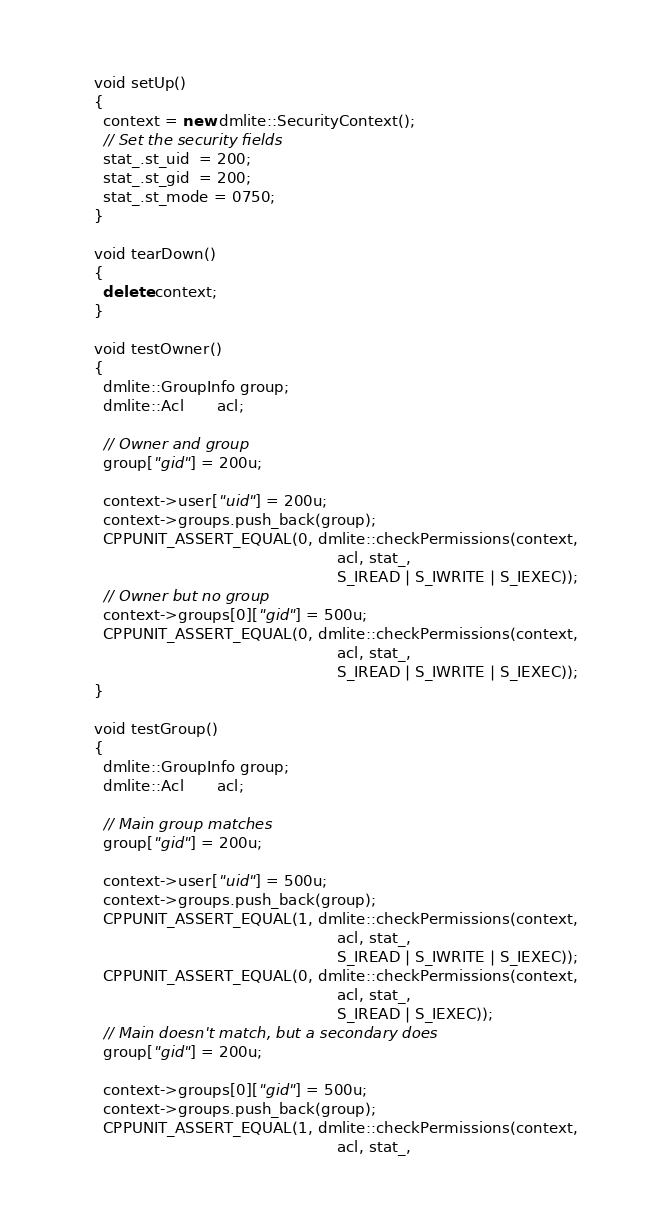Convert code to text. <code><loc_0><loc_0><loc_500><loc_500><_C++_>  void setUp()
  {
    context = new dmlite::SecurityContext();
    // Set the security fields
    stat_.st_uid  = 200;
    stat_.st_gid  = 200;
    stat_.st_mode = 0750;
  }

  void tearDown()
  {
    delete context;
  }

  void testOwner()
  {
    dmlite::GroupInfo group;
    dmlite::Acl       acl;
    
    // Owner and group
    group["gid"] = 200u;
    
    context->user["uid"] = 200u;
    context->groups.push_back(group);
    CPPUNIT_ASSERT_EQUAL(0, dmlite::checkPermissions(context,
                                                     acl, stat_,
                                                     S_IREAD | S_IWRITE | S_IEXEC));
    // Owner but no group
    context->groups[0]["gid"] = 500u;
    CPPUNIT_ASSERT_EQUAL(0, dmlite::checkPermissions(context,
                                                     acl, stat_,
                                                     S_IREAD | S_IWRITE | S_IEXEC));
  }

  void testGroup()
  {
    dmlite::GroupInfo group;
    dmlite::Acl       acl;
    
    // Main group matches
    group["gid"] = 200u;
    
    context->user["uid"] = 500u;
    context->groups.push_back(group);
    CPPUNIT_ASSERT_EQUAL(1, dmlite::checkPermissions(context,
                                                     acl, stat_,
                                                     S_IREAD | S_IWRITE | S_IEXEC));
    CPPUNIT_ASSERT_EQUAL(0, dmlite::checkPermissions(context,
                                                     acl, stat_,
                                                     S_IREAD | S_IEXEC));
    // Main doesn't match, but a secondary does
    group["gid"] = 200u;
    
    context->groups[0]["gid"] = 500u;
    context->groups.push_back(group);
    CPPUNIT_ASSERT_EQUAL(1, dmlite::checkPermissions(context,
                                                     acl, stat_,</code> 